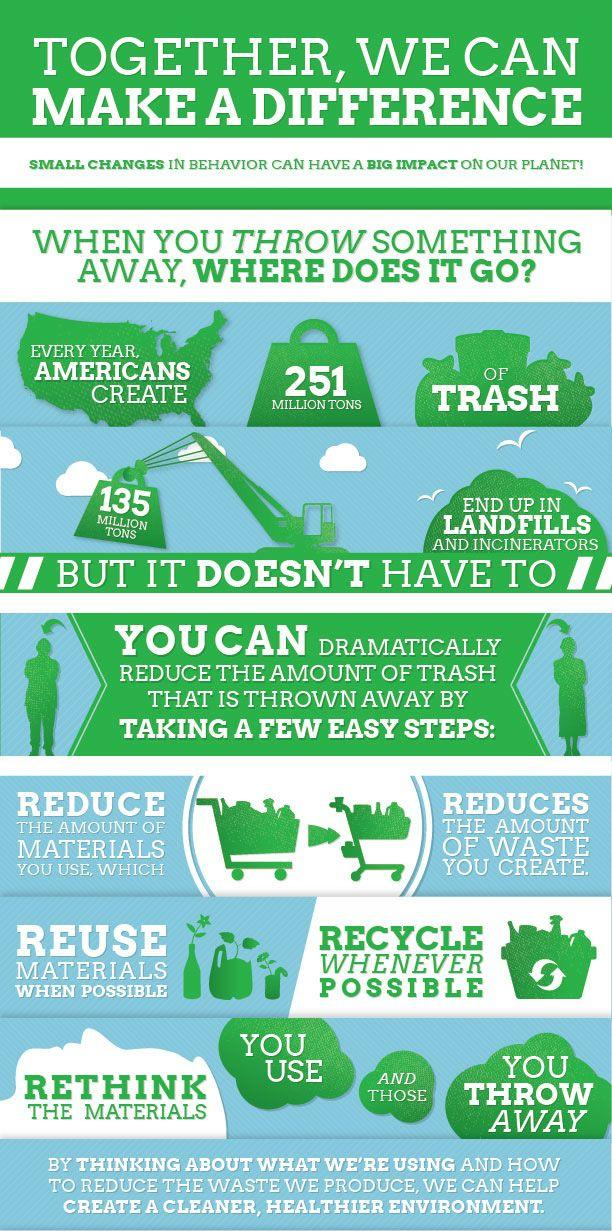Identify some key points in this picture. Every year, Americans generate approximately 251 million tons of trash. According to estimates, over 135 million tons of non-organic waste is generated and disposed of in landfills and incinerators each year. 